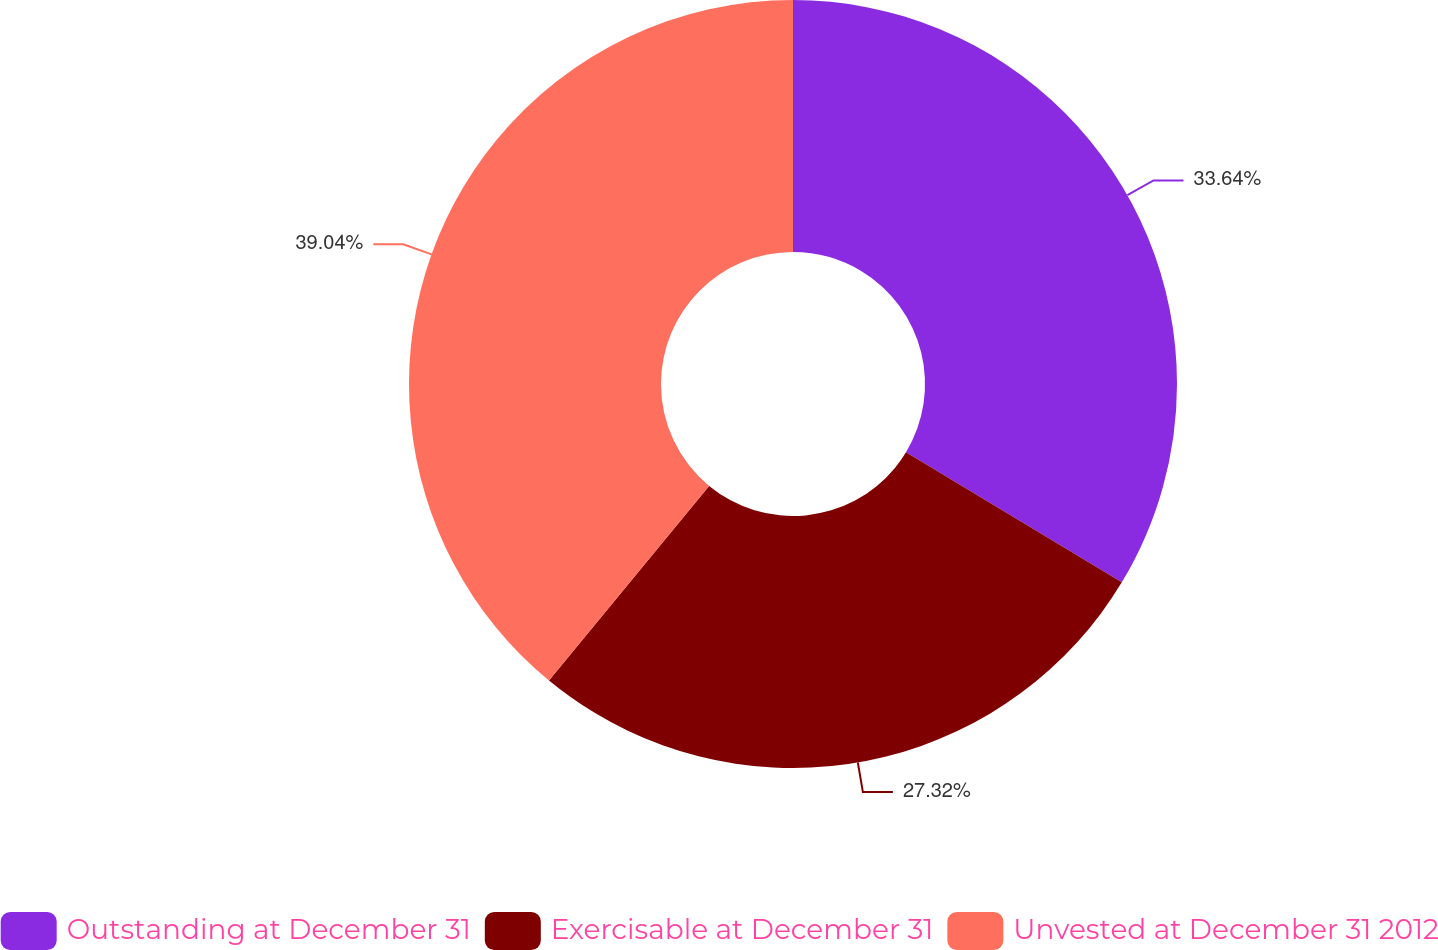Convert chart to OTSL. <chart><loc_0><loc_0><loc_500><loc_500><pie_chart><fcel>Outstanding at December 31<fcel>Exercisable at December 31<fcel>Unvested at December 31 2012<nl><fcel>33.64%<fcel>27.32%<fcel>39.04%<nl></chart> 